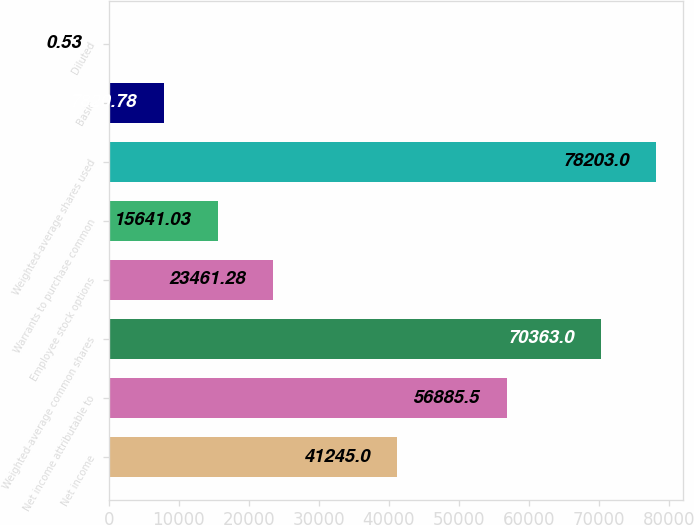Convert chart to OTSL. <chart><loc_0><loc_0><loc_500><loc_500><bar_chart><fcel>Net income<fcel>Net income attributable to<fcel>Weighted-average common shares<fcel>Employee stock options<fcel>Warrants to purchase common<fcel>Weighted-average shares used<fcel>Basic<fcel>Diluted<nl><fcel>41245<fcel>56885.5<fcel>70363<fcel>23461.3<fcel>15641<fcel>78203<fcel>7820.78<fcel>0.53<nl></chart> 